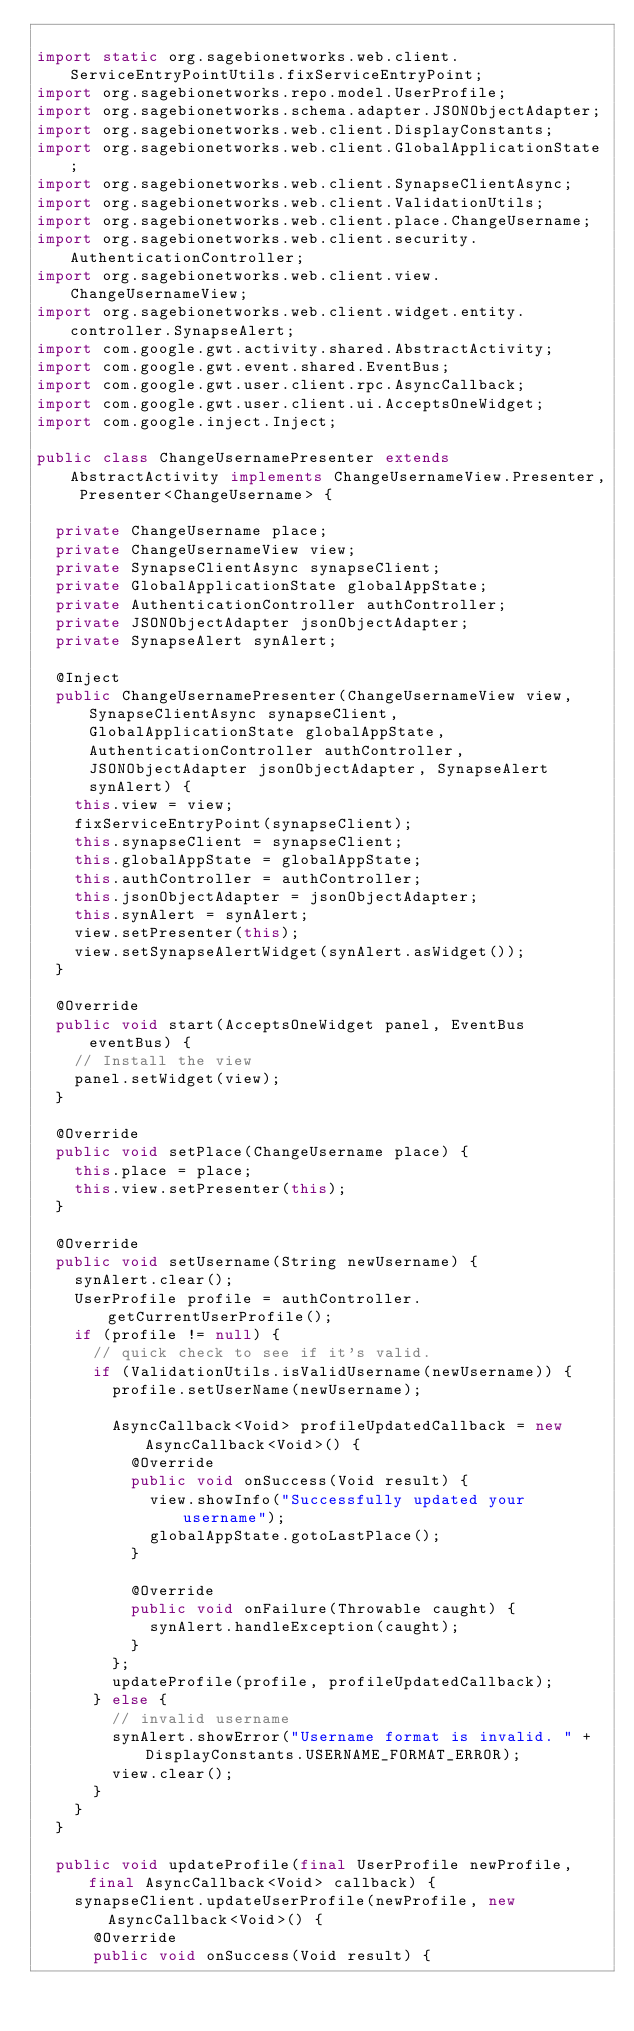Convert code to text. <code><loc_0><loc_0><loc_500><loc_500><_Java_>
import static org.sagebionetworks.web.client.ServiceEntryPointUtils.fixServiceEntryPoint;
import org.sagebionetworks.repo.model.UserProfile;
import org.sagebionetworks.schema.adapter.JSONObjectAdapter;
import org.sagebionetworks.web.client.DisplayConstants;
import org.sagebionetworks.web.client.GlobalApplicationState;
import org.sagebionetworks.web.client.SynapseClientAsync;
import org.sagebionetworks.web.client.ValidationUtils;
import org.sagebionetworks.web.client.place.ChangeUsername;
import org.sagebionetworks.web.client.security.AuthenticationController;
import org.sagebionetworks.web.client.view.ChangeUsernameView;
import org.sagebionetworks.web.client.widget.entity.controller.SynapseAlert;
import com.google.gwt.activity.shared.AbstractActivity;
import com.google.gwt.event.shared.EventBus;
import com.google.gwt.user.client.rpc.AsyncCallback;
import com.google.gwt.user.client.ui.AcceptsOneWidget;
import com.google.inject.Inject;

public class ChangeUsernamePresenter extends AbstractActivity implements ChangeUsernameView.Presenter, Presenter<ChangeUsername> {

	private ChangeUsername place;
	private ChangeUsernameView view;
	private SynapseClientAsync synapseClient;
	private GlobalApplicationState globalAppState;
	private AuthenticationController authController;
	private JSONObjectAdapter jsonObjectAdapter;
	private SynapseAlert synAlert;

	@Inject
	public ChangeUsernamePresenter(ChangeUsernameView view, SynapseClientAsync synapseClient, GlobalApplicationState globalAppState, AuthenticationController authController, JSONObjectAdapter jsonObjectAdapter, SynapseAlert synAlert) {
		this.view = view;
		fixServiceEntryPoint(synapseClient);
		this.synapseClient = synapseClient;
		this.globalAppState = globalAppState;
		this.authController = authController;
		this.jsonObjectAdapter = jsonObjectAdapter;
		this.synAlert = synAlert;
		view.setPresenter(this);
		view.setSynapseAlertWidget(synAlert.asWidget());
	}

	@Override
	public void start(AcceptsOneWidget panel, EventBus eventBus) {
		// Install the view
		panel.setWidget(view);
	}

	@Override
	public void setPlace(ChangeUsername place) {
		this.place = place;
		this.view.setPresenter(this);
	}

	@Override
	public void setUsername(String newUsername) {
		synAlert.clear();
		UserProfile profile = authController.getCurrentUserProfile();
		if (profile != null) {
			// quick check to see if it's valid.
			if (ValidationUtils.isValidUsername(newUsername)) {
				profile.setUserName(newUsername);

				AsyncCallback<Void> profileUpdatedCallback = new AsyncCallback<Void>() {
					@Override
					public void onSuccess(Void result) {
						view.showInfo("Successfully updated your username");
						globalAppState.gotoLastPlace();
					}

					@Override
					public void onFailure(Throwable caught) {
						synAlert.handleException(caught);
					}
				};
				updateProfile(profile, profileUpdatedCallback);
			} else {
				// invalid username
				synAlert.showError("Username format is invalid. " + DisplayConstants.USERNAME_FORMAT_ERROR);
				view.clear();
			}
		}
	}

	public void updateProfile(final UserProfile newProfile, final AsyncCallback<Void> callback) {
		synapseClient.updateUserProfile(newProfile, new AsyncCallback<Void>() {
			@Override
			public void onSuccess(Void result) {</code> 